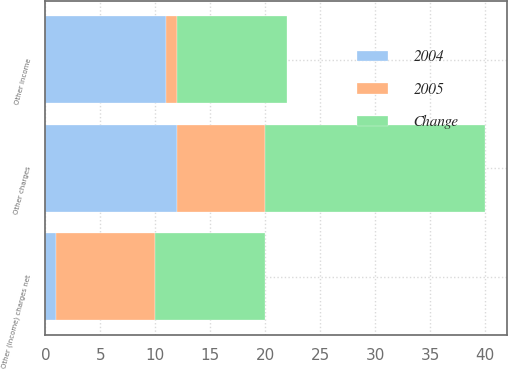Convert chart to OTSL. <chart><loc_0><loc_0><loc_500><loc_500><stacked_bar_chart><ecel><fcel>Other income<fcel>Other charges<fcel>Other (income) charges net<nl><fcel>2004<fcel>11<fcel>12<fcel>1<nl><fcel>Change<fcel>10<fcel>20<fcel>10<nl><fcel>2005<fcel>1<fcel>8<fcel>9<nl></chart> 